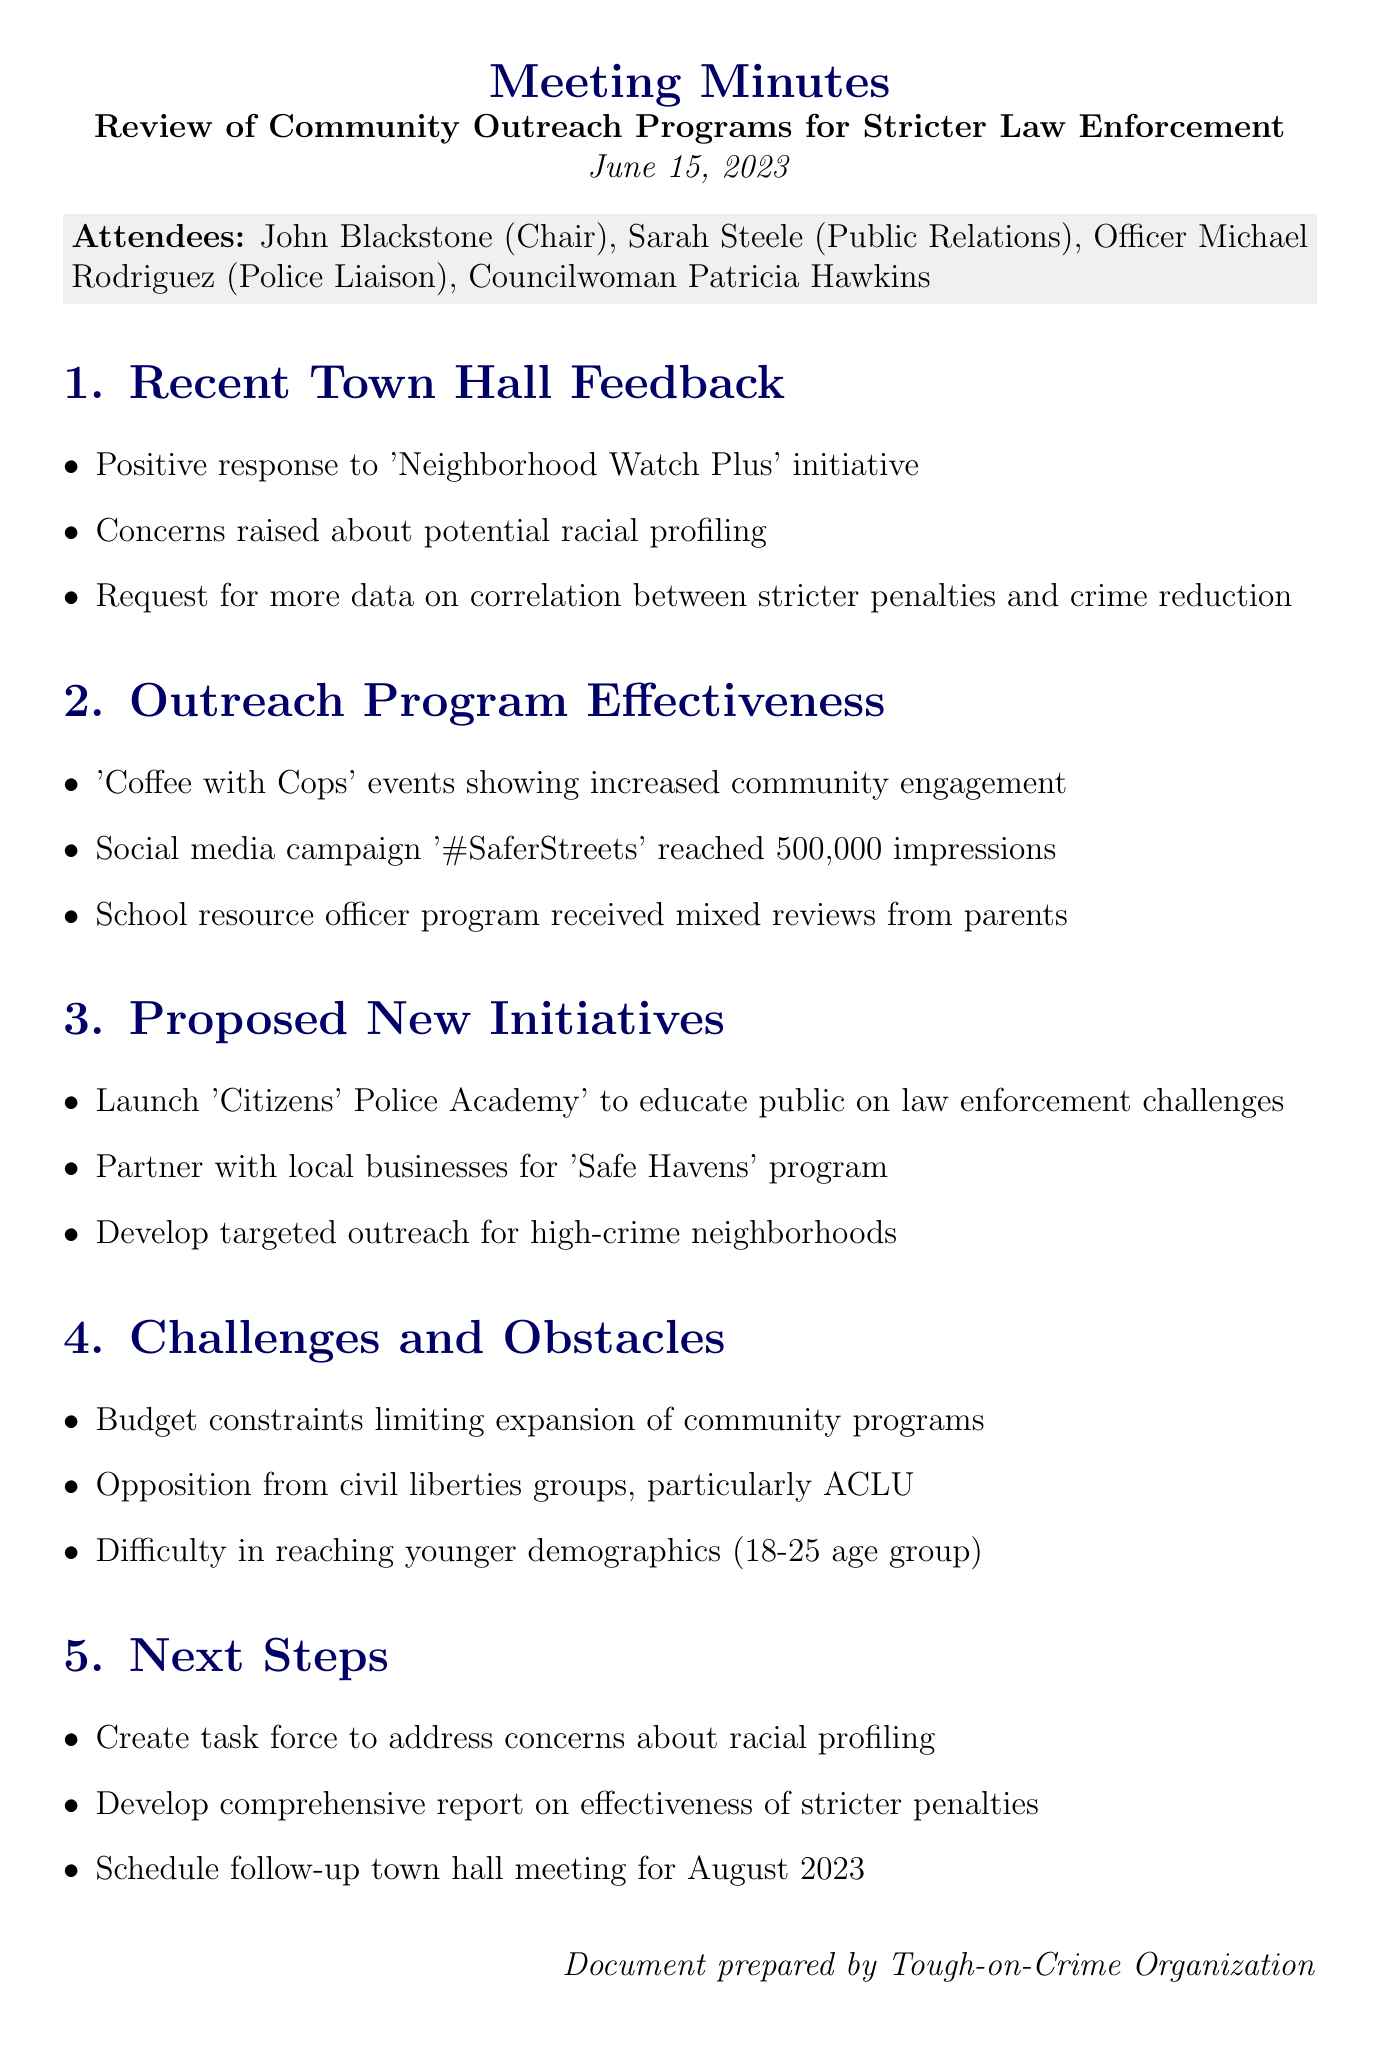What is the meeting date? The meeting date is clearly stated in the document header.
Answer: June 15, 2023 Who is the Chair of the meeting? The Chair is mentioned in the list of attendees.
Answer: John Blackstone What initiative received a positive response? The document lists initiatives in the feedback section.
Answer: Neighborhood Watch Plus How many impressions did the '#SaferStreets' campaign reach? The document provides specific metrics related to outreach effectiveness.
Answer: 500,000 impressions What are the proposed new initiatives? This information is contained in the section regarding proposed new initiatives.
Answer: Citizens' Police Academy What is one challenge mentioned during the meeting? The challenges faced are listed in the respective section of the document.
Answer: Budget constraints When is the next scheduled town hall meeting? The date for the follow-up town hall meeting is mentioned in the next steps section.
Answer: August 2023 What is the main concern raised about racial profiling? The document outlines feedback and concerns from the town hall meetings.
Answer: Potential racial profiling What initiative aims to educate the public on law enforcement challenges? This initiative is specifically identified among the proposed new initiatives in the document.
Answer: Citizens' Police Academy 